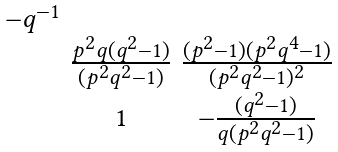Convert formula to latex. <formula><loc_0><loc_0><loc_500><loc_500>\begin{smallmatrix} - q ^ { - 1 } & & \\ & \frac { p ^ { 2 } q ( q ^ { 2 } - 1 ) } { ( p ^ { 2 } q ^ { 2 } - 1 ) } & \frac { ( p ^ { 2 } - 1 ) ( p ^ { 2 } q ^ { 4 } - 1 ) } { ( p ^ { 2 } q ^ { 2 } - 1 ) ^ { 2 } } \\ & 1 & - \frac { ( q ^ { 2 } - 1 ) } { q ( p ^ { 2 } q ^ { 2 } - 1 ) } \end{smallmatrix}</formula> 